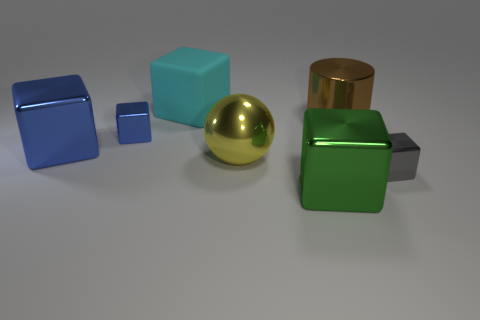Can you compare the sizes of the green and blue cubes for me? Certainly, the green cube is larger than the blue cube immediately to its left. The green cube's dimensions appear to be approximately twice those of the smaller blue cube. Which is the brightest object in the image? The brightest object is the gold sphere. Its surface is highly reflective and shiny, which makes it appear to be the most luminous among the objects. 